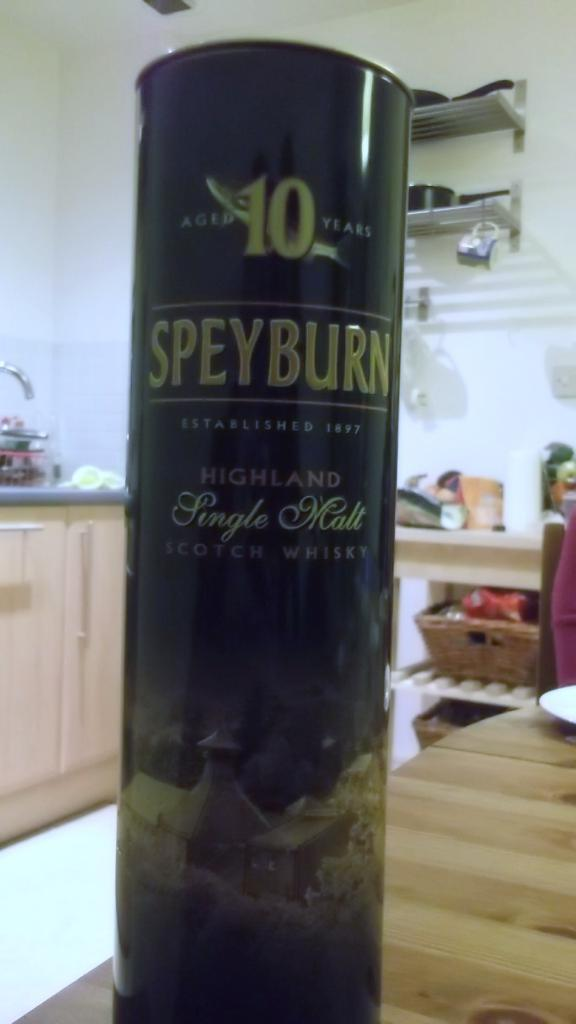Provide a one-sentence caption for the provided image. A cylinder of whiskey sits on a counter top. 